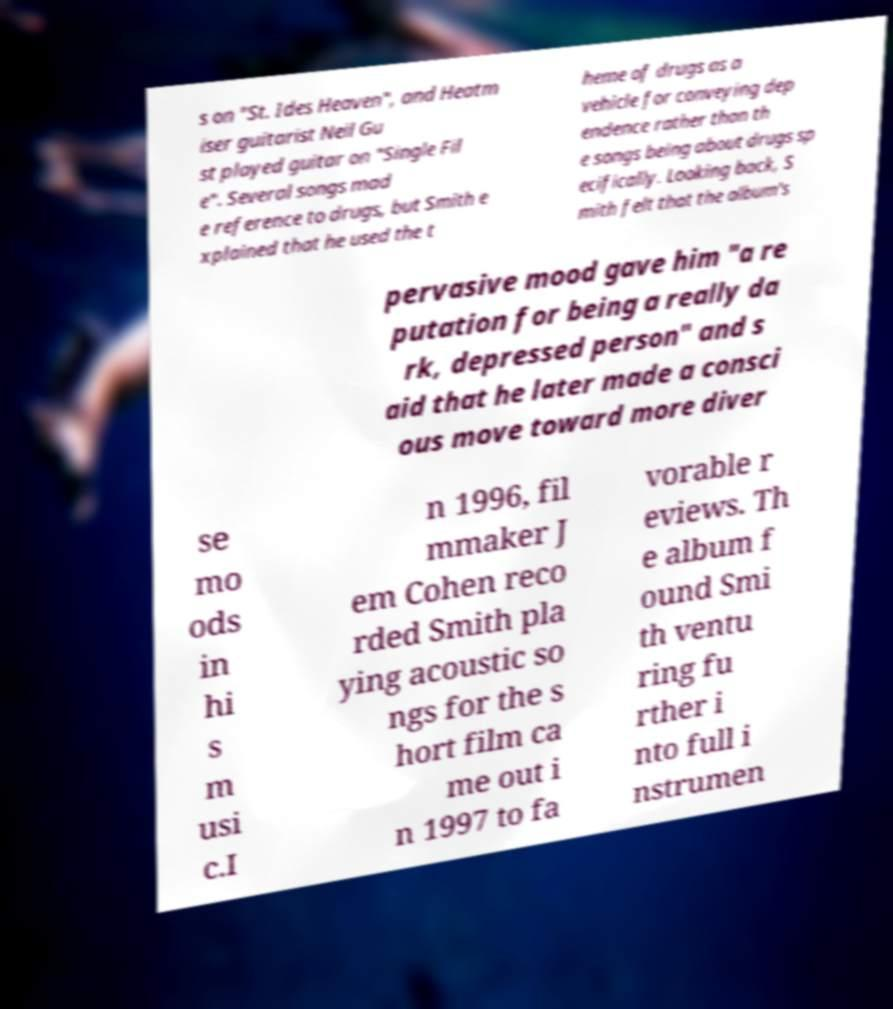There's text embedded in this image that I need extracted. Can you transcribe it verbatim? s on "St. Ides Heaven", and Heatm iser guitarist Neil Gu st played guitar on "Single Fil e". Several songs mad e reference to drugs, but Smith e xplained that he used the t heme of drugs as a vehicle for conveying dep endence rather than th e songs being about drugs sp ecifically. Looking back, S mith felt that the album's pervasive mood gave him "a re putation for being a really da rk, depressed person" and s aid that he later made a consci ous move toward more diver se mo ods in hi s m usi c.I n 1996, fil mmaker J em Cohen reco rded Smith pla ying acoustic so ngs for the s hort film ca me out i n 1997 to fa vorable r eviews. Th e album f ound Smi th ventu ring fu rther i nto full i nstrumen 